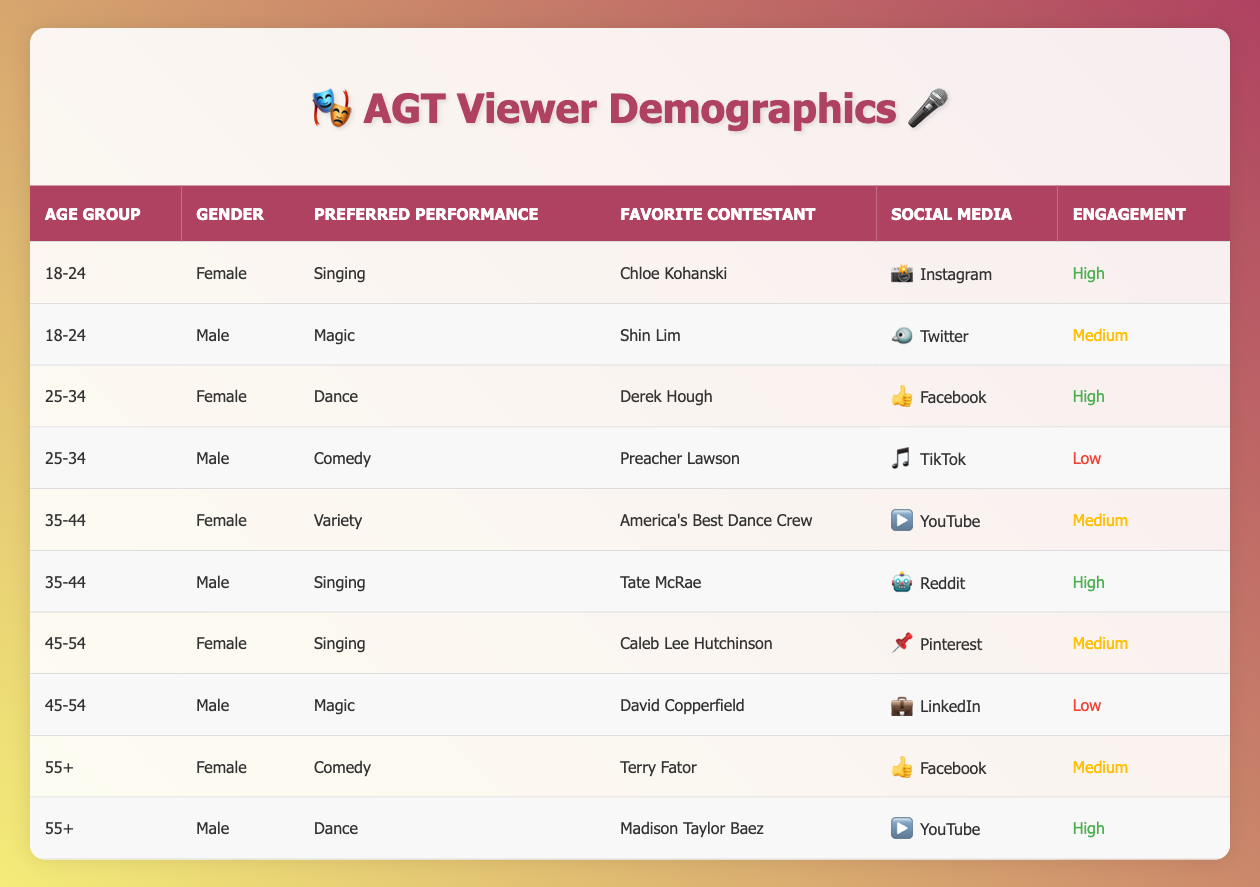What is the most preferred performance type among viewers aged 18-24? The table shows two entries for the age group 18-24. One is for a female viewer who prefers singing, and the other is for a male viewer who prefers magic. Since singing is mentioned as a favorite performance type once, it is the most preferred performance type in that group.
Answer: Singing How many male viewers aged 35-44 prefer singing? There is one entry for a male viewer aged 35-44 who prefers singing, which is Tate McRae in the table. Therefore, the count is 1.
Answer: 1 Which social media platform has the highest engagement among female viewers aged 25-34? In the table, the female viewer aged 25-34 who prefers dance and follows Derek Hough shows a high engagement level on Facebook. There is no other female viewer in that age group with a higher engagement level.
Answer: Facebook Is there a viewer aged 45-54 who prefers magic? The table indicates that there is one male viewer aged 45-54 who prefers magic, specifically David Copperfield. Thus, the answer is yes.
Answer: Yes What is the average engagement level of male viewers who prefer singing? There are two male viewers who prefer singing: one aged 35-44 with high engagement and another from the age group 18-24 with medium engagement. Assigning numerical values (high=3, medium=2), we calculate the average as (3 + 2) / 2 = 2.5, which translates to medium engagement.
Answer: Medium Which age group has the most male viewers preferring comedy? The table shows one male viewer aged 25-34 preferring comedy and one viewer aged 55+ preferring comedy as well. Both age groups have only one male viewer each, indicating a tie.
Answer: Both age groups (25-34 and 55+) What is the preferred performance type of the oldest female viewer? There is one entry for a female viewer aged 55+, and her preferred performance type is comedy, associated with Terry Fator. Therefore, her preference is comedy.
Answer: Comedy How many viewers prefer singing across all age groups and genders? By checking each entry in the table, we find that three viewers prefer singing: one female viewer aged 18-24, one male viewer aged 35-44, and one female viewer aged 45-54. Adding these up gives a total of three.
Answer: 3 Is there any male viewer aged 55+ who has high engagement? The table has one male viewer aged 55+ who prefers dance, and his engagement level is high. Therefore, the answer is yes.
Answer: Yes What percentage of female viewers prefer dance? There are four female viewers detailed in the table. One prefers dance, so the calculation is (1/4) * 100 = 25%.
Answer: 25% Which social media platform is favored by the male viewer aged 45-54 who prefers magic? The table states that the male viewer aged 45-54 who prefers magic uses LinkedIn as his social media platform.
Answer: LinkedIn 